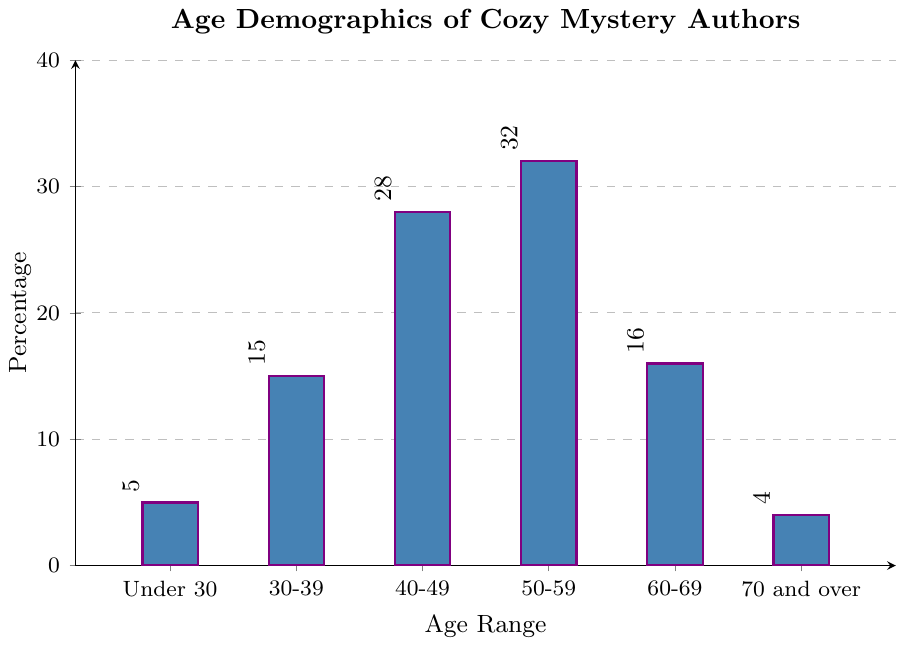Which age range has the highest percentage of cozy mystery authors? By looking at the height of the bars in the chart, the bar labeled "50-59" is the tallest, indicating the highest percentage.
Answer: 50-59 What is the combined percentage of authors aged 50 and above? Sum the percentages of the age ranges 50-59, 60-69, and 70 and over: 32% + 16% + 4% = 52%
Answer: 52% How does the percentage of authors under 30 compare to those aged 30-39? The percentage for under 30 is 5%, while for 30-39, it is 15%. 5% is less than 15%.
Answer: less Which age range has the lowest percentage of authors? By observing the bars, the "70 and over" category has the shortest bar, corresponding to the lowest percentage.
Answer: 70 and over What is the difference in percentage between the 40-49 and 60-69 age ranges? Subtract the percentage for 60-69 from that of 40-49: 28% - 16% = 12%
Answer: 12% What percentage of authors are aged 30-49? Sum the percentages for the age ranges 30-39 and 40-49: 15% + 28% = 43%
Answer: 43% Which age category has a percentage closest to 20%? The bars for 30-39 and 60-69 are compared. 16% is closer to 20% than 15%.
Answer: 60-69 What is the average percentage for the age ranges under 30 and 70 and over? Sum the percentages for under 30 and 70 and over, then divide by 2: (5% + 4%) / 2 = 4.5%
Answer: 4.5% Is the percentage of authors in the 50-59 age range greater than the combined percentage of authors aged 30-39 and 60-69? Compare the 50-59 percentage with the sum of 30-39 and 60-69: 32% > (15% + 16%) = 31%
Answer: yes 